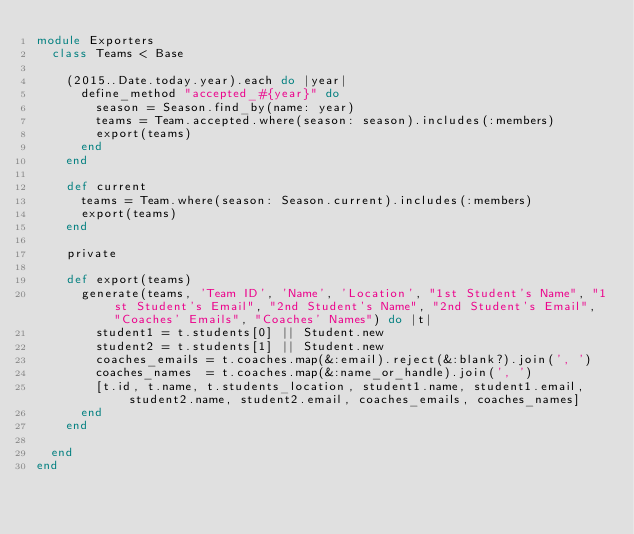<code> <loc_0><loc_0><loc_500><loc_500><_Ruby_>module Exporters
  class Teams < Base

    (2015..Date.today.year).each do |year|
      define_method "accepted_#{year}" do
        season = Season.find_by(name: year)
        teams = Team.accepted.where(season: season).includes(:members)
        export(teams)
      end
    end

    def current
      teams = Team.where(season: Season.current).includes(:members)
      export(teams)
    end

    private

    def export(teams)
      generate(teams, 'Team ID', 'Name', 'Location', "1st Student's Name", "1st Student's Email", "2nd Student's Name", "2nd Student's Email", "Coaches' Emails", "Coaches' Names") do |t|
        student1 = t.students[0] || Student.new
        student2 = t.students[1] || Student.new
        coaches_emails = t.coaches.map(&:email).reject(&:blank?).join(', ')
        coaches_names  = t.coaches.map(&:name_or_handle).join(', ')
        [t.id, t.name, t.students_location, student1.name, student1.email, student2.name, student2.email, coaches_emails, coaches_names]
      end
    end

  end
end
</code> 